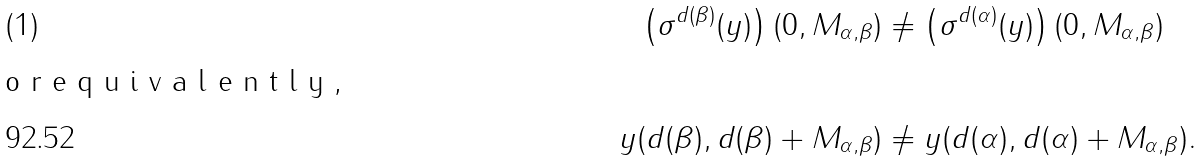<formula> <loc_0><loc_0><loc_500><loc_500>\left ( \sigma ^ { d ( \beta ) } ( y ) \right ) ( 0 , M _ { \alpha , \beta } ) & \neq \left ( \sigma ^ { d ( \alpha ) } ( y ) \right ) ( 0 , M _ { \alpha , \beta } ) \intertext { o r e q u i v a l e n t l y , } y ( d ( \beta ) , d ( \beta ) + M _ { \alpha , \beta } ) & \neq y ( d ( \alpha ) , d ( \alpha ) + M _ { \alpha , \beta } ) .</formula> 